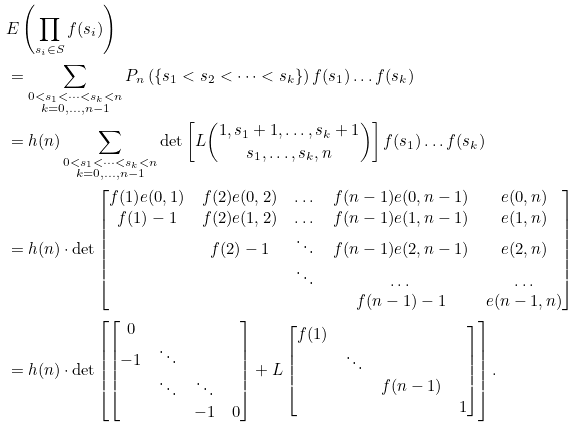Convert formula to latex. <formula><loc_0><loc_0><loc_500><loc_500>& E \left ( \prod _ { s _ { i } \in S } f ( s _ { i } ) \right ) \\ & = \sum _ { \substack { 0 < s _ { 1 } < \dots < s _ { k } < n \\ k = 0 , \dots , n - 1 } } P _ { n } \left ( \{ s _ { 1 } < s _ { 2 } < \dots < s _ { k } \} \right ) f ( s _ { 1 } ) \dots f ( s _ { k } ) \\ & = h ( n ) \sum _ { \substack { 0 < s _ { 1 } < \dots < s _ { k } < n \\ k = 0 , \dots , n - 1 } } \text {det} \left [ L \binom { 1 , s _ { 1 } + 1 , \dots , s _ { k } + 1 } { s _ { 1 } , \dots , s _ { k } , n } \right ] f ( s _ { 1 } ) \dots f ( s _ { k } ) \\ & = h ( n ) \cdot \text {det} \begin{bmatrix} f ( 1 ) e ( 0 , 1 ) & f ( 2 ) e ( 0 , 2 ) & \dots & f ( n - 1 ) e ( 0 , n - 1 ) & e ( 0 , n ) \\ f ( 1 ) - 1 & f ( 2 ) e ( 1 , 2 ) & \dots & f ( n - 1 ) e ( 1 , n - 1 ) & e ( 1 , n ) \\ & f ( 2 ) - 1 & \ddots & f ( n - 1 ) e ( 2 , n - 1 ) & e ( 2 , n ) \\ & & \ddots & \dots & \dots \\ & & & f ( n - 1 ) - 1 & e ( n - 1 , n ) \end{bmatrix} \\ & = h ( n ) \cdot \text {det} \left [ \begin{bmatrix} 0 & & & \\ - 1 & \ddots & & \\ & \ddots & \ddots & \\ & & - 1 & 0 \end{bmatrix} + L \begin{bmatrix} f ( 1 ) & & & \\ & \ddots & & \\ & & f ( n - 1 ) & \\ & & & 1 \end{bmatrix} \right ] .</formula> 